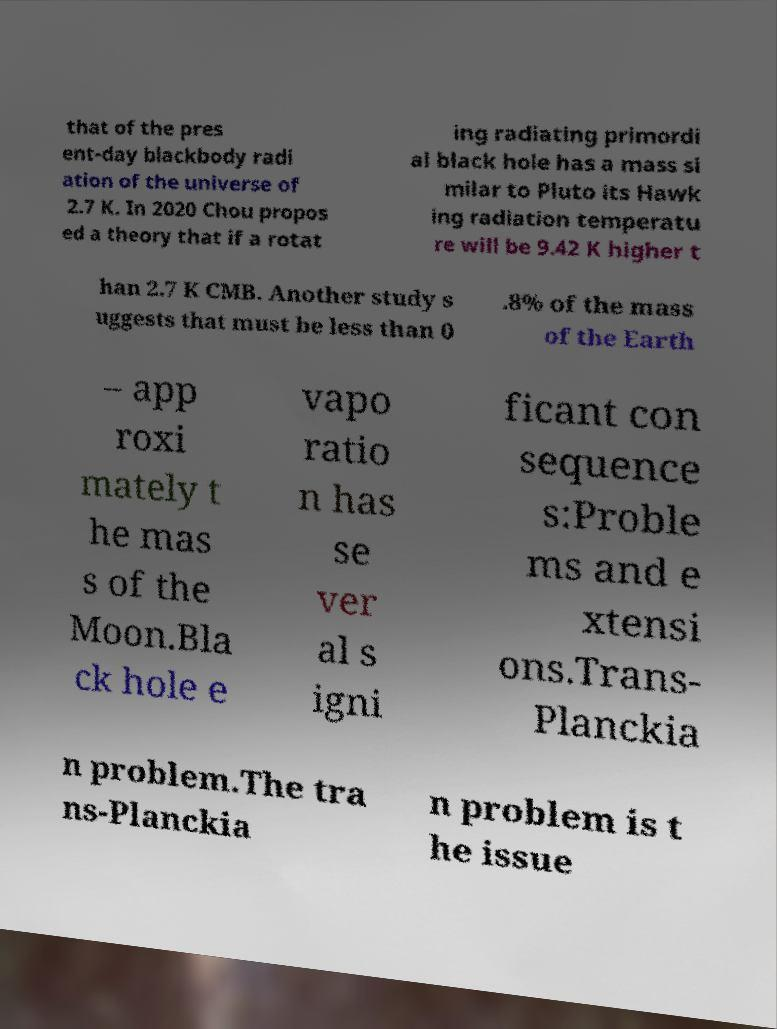Can you read and provide the text displayed in the image?This photo seems to have some interesting text. Can you extract and type it out for me? that of the pres ent-day blackbody radi ation of the universe of 2.7 K. In 2020 Chou propos ed a theory that if a rotat ing radiating primordi al black hole has a mass si milar to Pluto its Hawk ing radiation temperatu re will be 9.42 K higher t han 2.7 K CMB. Another study s uggests that must be less than 0 .8% of the mass of the Earth – app roxi mately t he mas s of the Moon.Bla ck hole e vapo ratio n has se ver al s igni ficant con sequence s:Proble ms and e xtensi ons.Trans- Planckia n problem.The tra ns-Planckia n problem is t he issue 